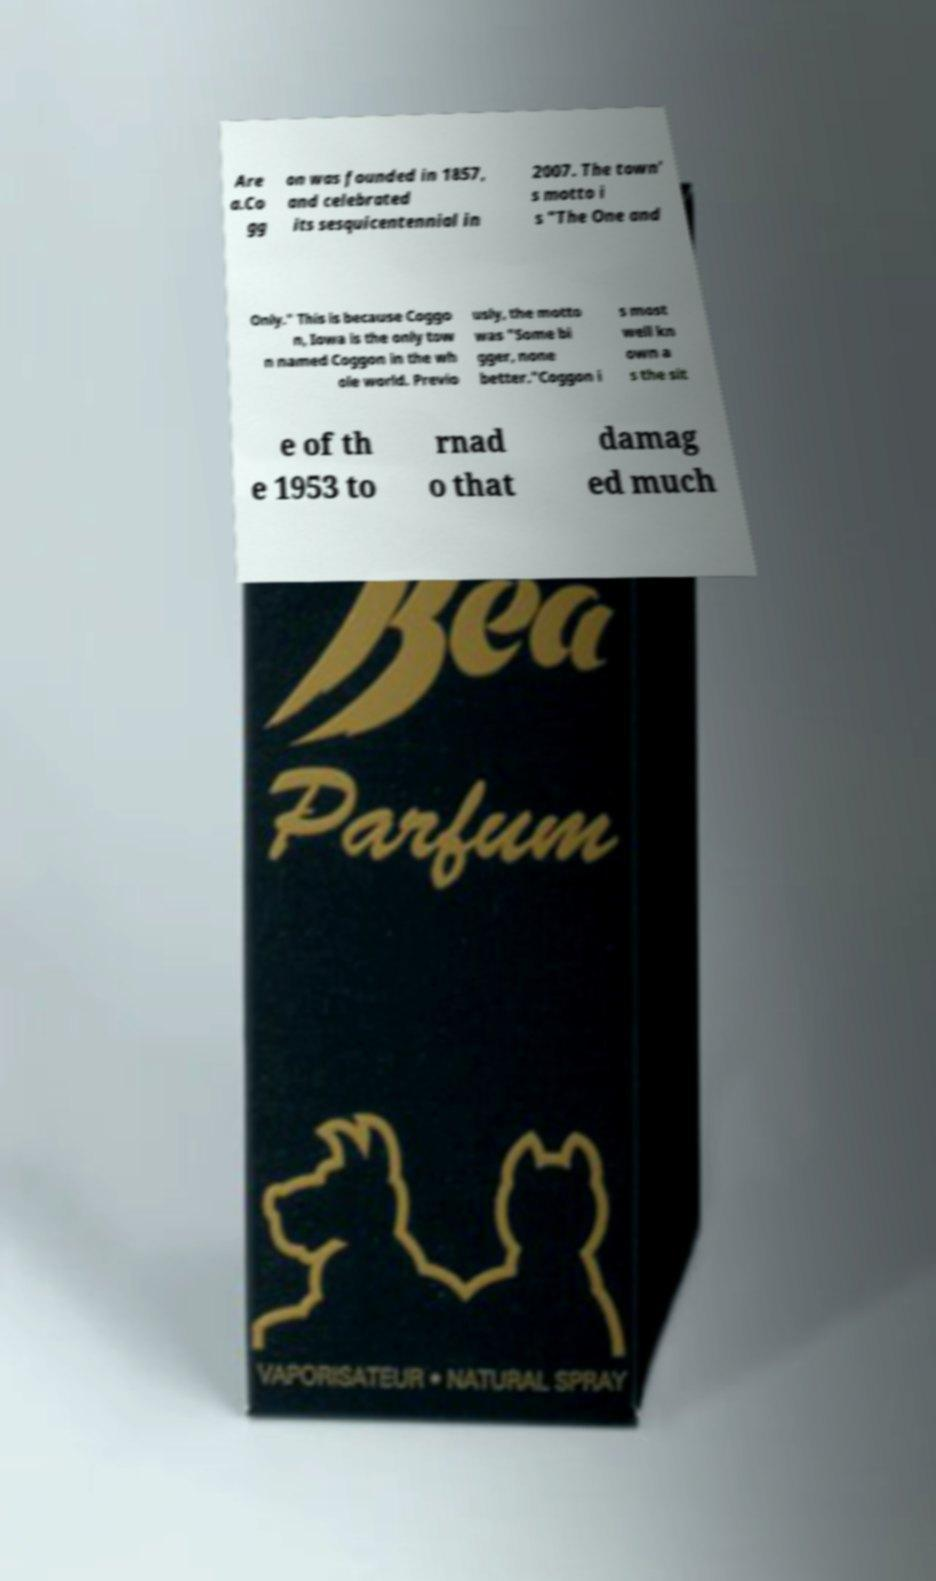Can you accurately transcribe the text from the provided image for me? Are a.Co gg on was founded in 1857, and celebrated its sesquicentennial in 2007. The town' s motto i s "The One and Only." This is because Coggo n, Iowa is the only tow n named Coggon in the wh ole world. Previo usly, the motto was "Some bi gger, none better."Coggon i s most well kn own a s the sit e of th e 1953 to rnad o that damag ed much 